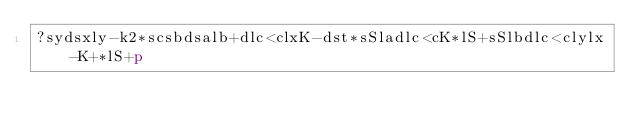Convert code to text. <code><loc_0><loc_0><loc_500><loc_500><_dc_>?sydsxly-k2*scsbdsalb+dlc<clxK-dst*sSladlc<cK*lS+sSlbdlc<clylx-K+*lS+p</code> 